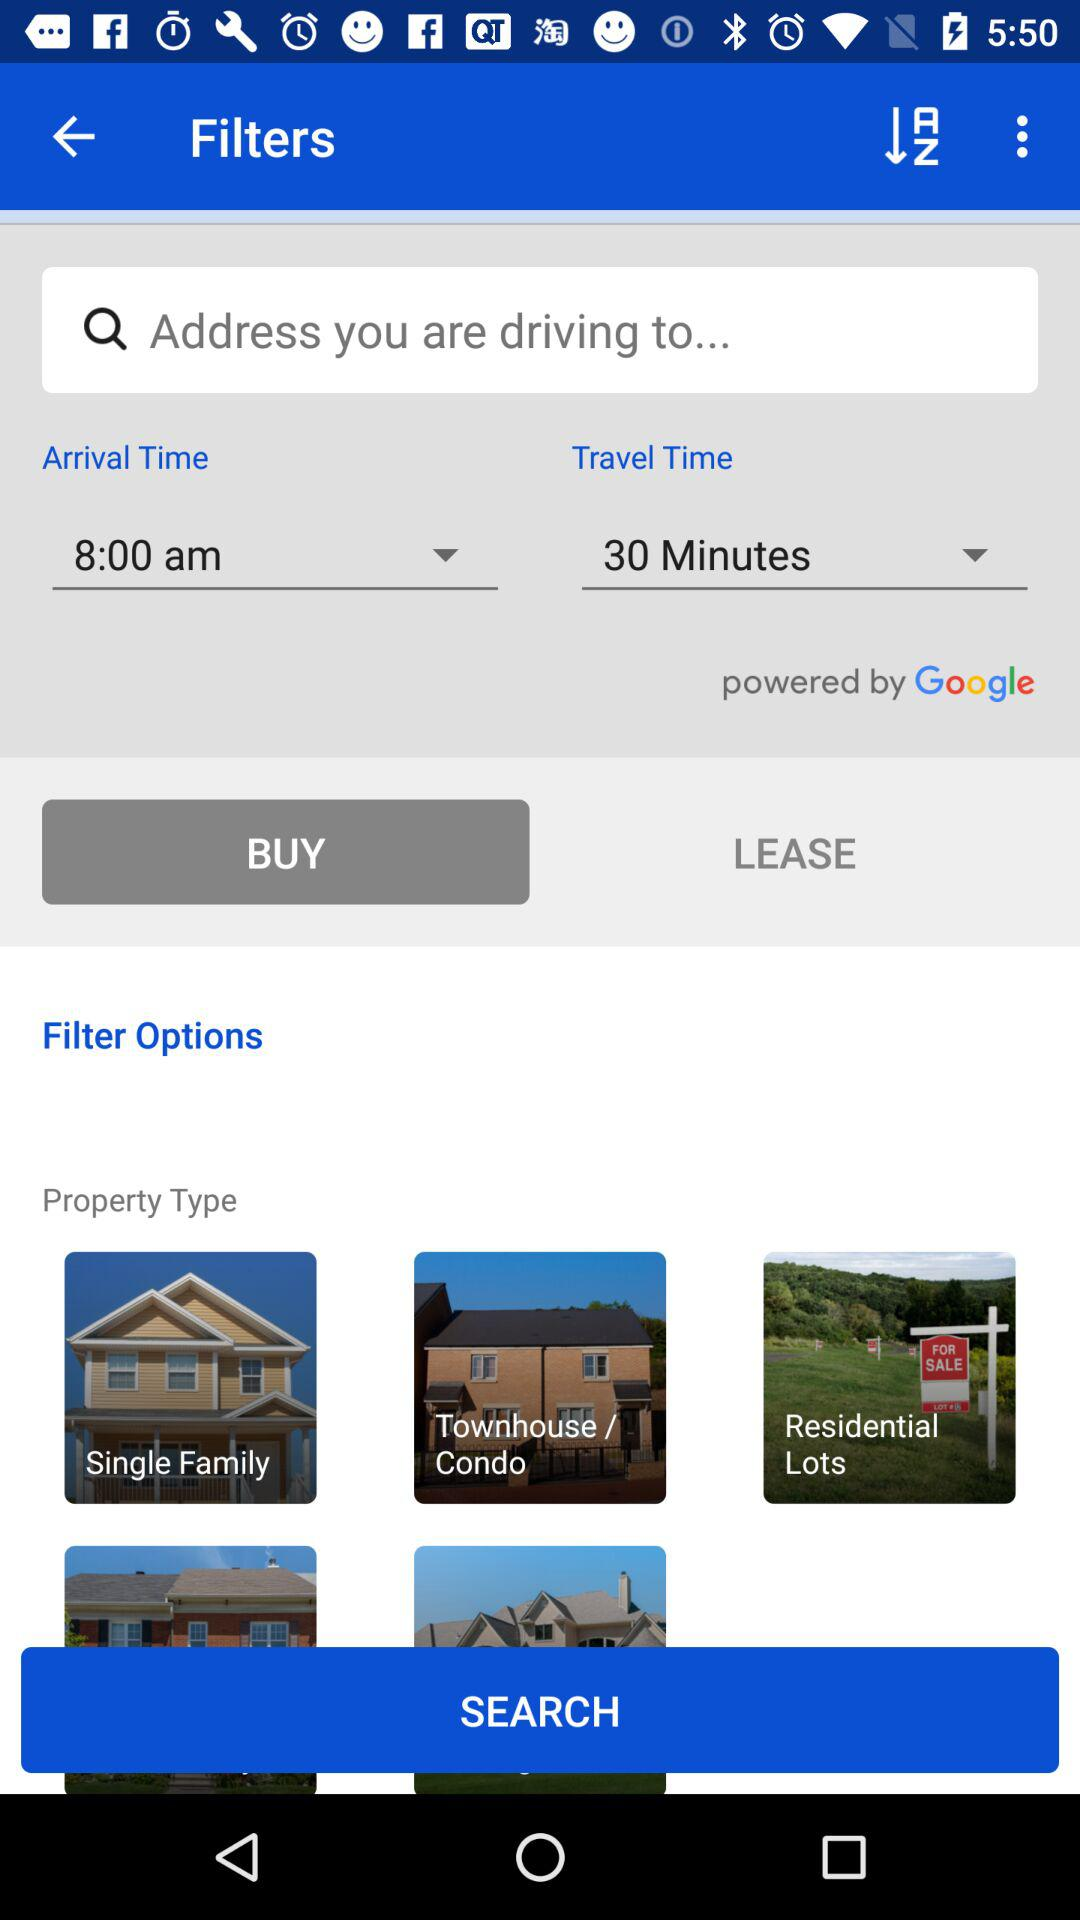What's the travel time? The travel time is 30 minutes. 